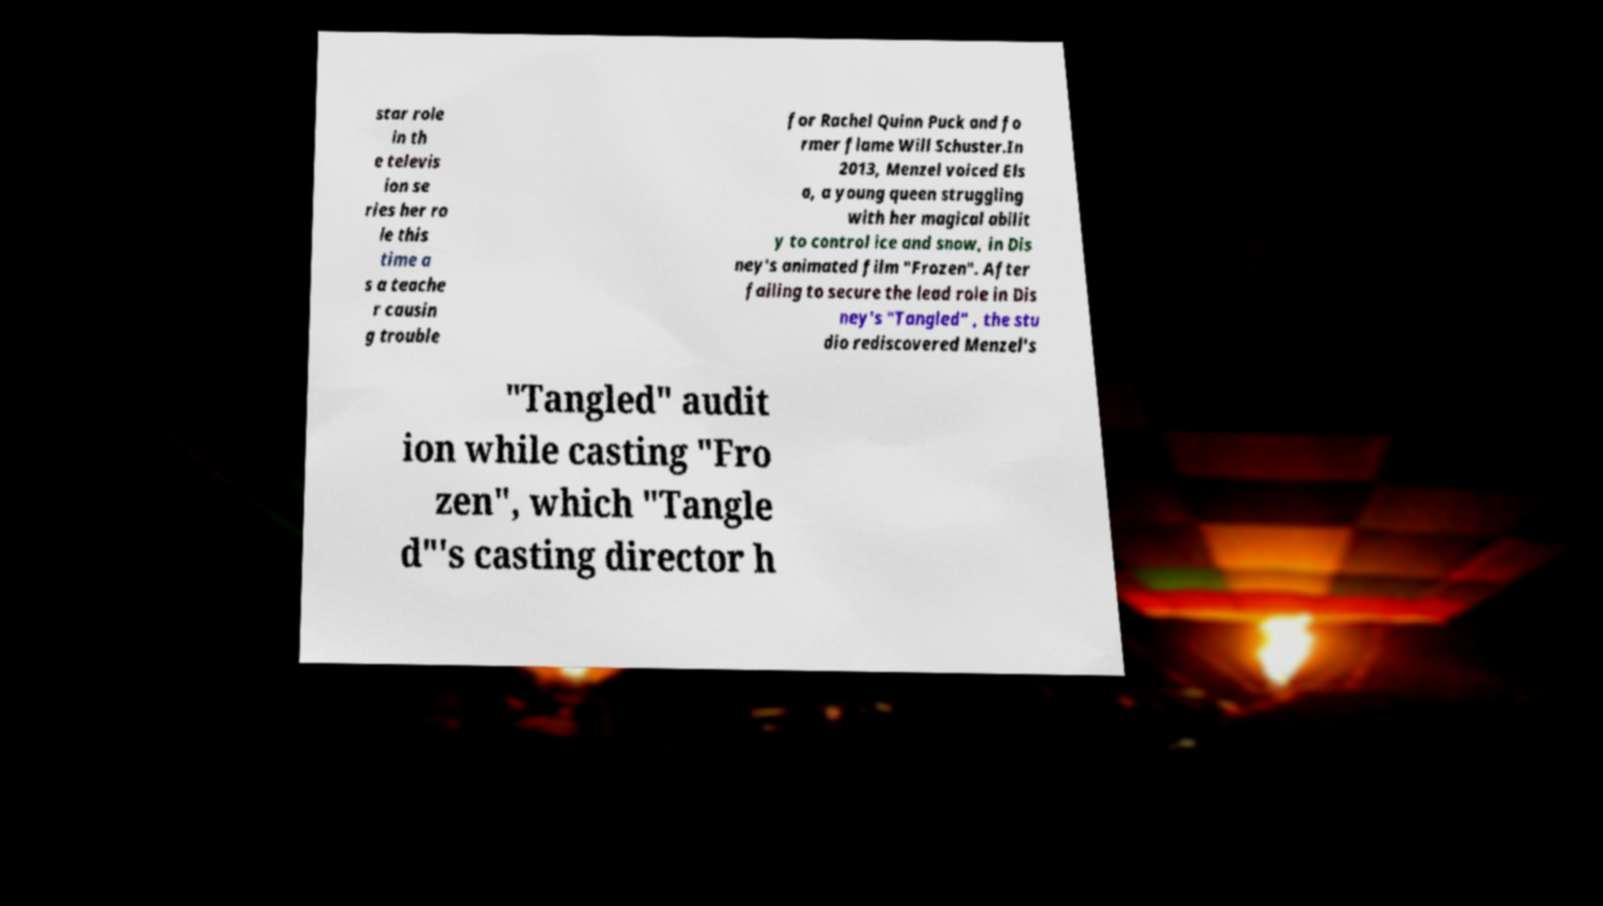Please read and relay the text visible in this image. What does it say? star role in th e televis ion se ries her ro le this time a s a teache r causin g trouble for Rachel Quinn Puck and fo rmer flame Will Schuster.In 2013, Menzel voiced Els a, a young queen struggling with her magical abilit y to control ice and snow, in Dis ney's animated film "Frozen". After failing to secure the lead role in Dis ney's "Tangled" , the stu dio rediscovered Menzel's "Tangled" audit ion while casting "Fro zen", which "Tangle d"'s casting director h 